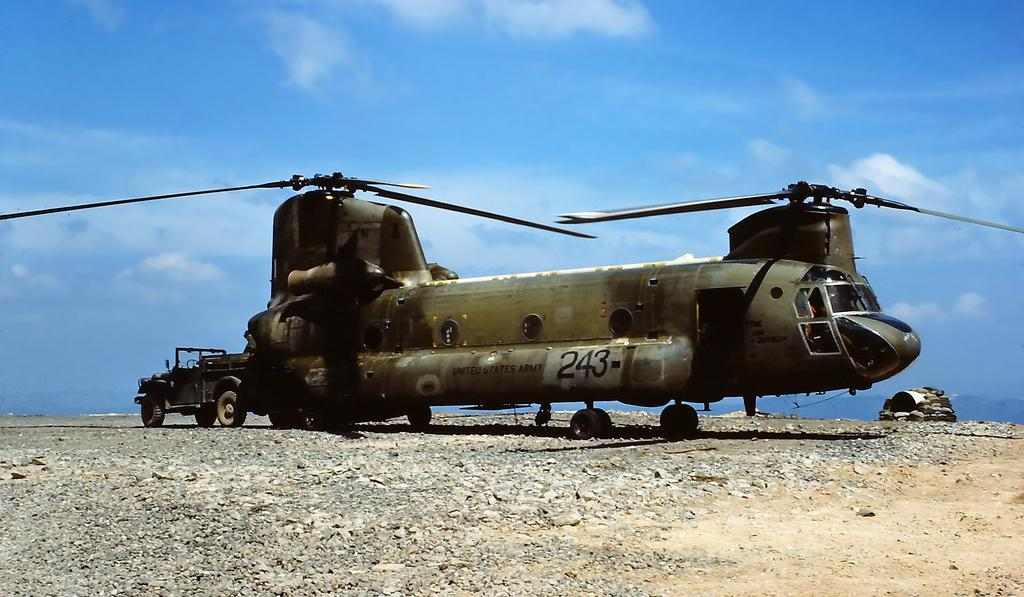What is the main subject of the image? The main subject of the image is an aircraft. What can be seen written on the aircraft? There is something written on the aircraft. What other type of vehicle is present in the image? There is a vehicle in the image. What is on the ground in the image? There are stones on the ground in the image. What is visible in the background of the image? There is sky visible in the background of the image. What can be observed in the sky? There are clouds in the sky. What type of curtain is hanging in the aircraft in the image? There is no curtain present in the aircraft or the image. How many memories can be seen in the image? Memories are not visible in the image, as they are intangible experiences. 